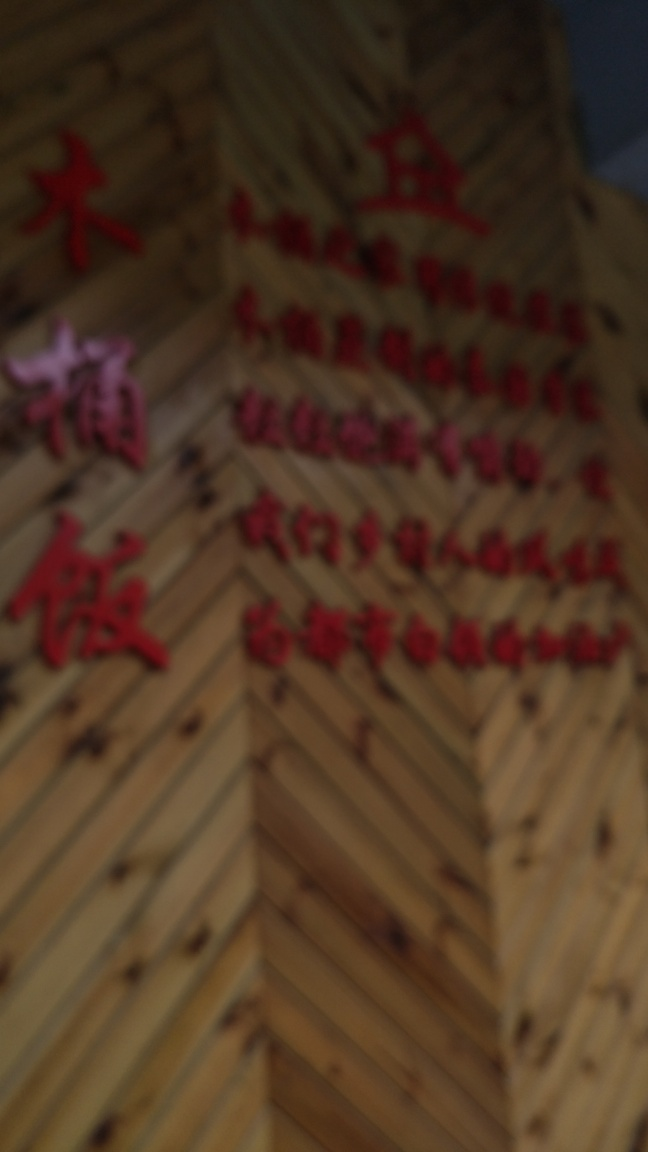What could be the reason for the blurriness in this image? The blurriness could be due to several factors such as camera movement during the shot, incorrect focus settings on the camera, or a deliberate artistic choice. It could also be the result of a low-quality lens or environmental conditions affecting the shot, like fog or smearing on the lens. 